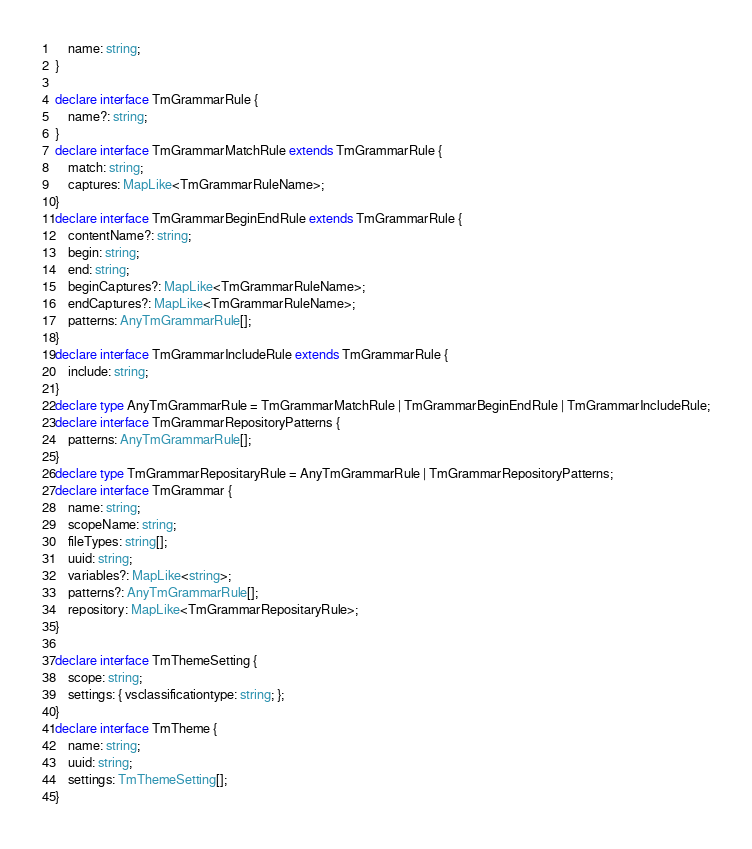<code> <loc_0><loc_0><loc_500><loc_500><_TypeScript_>    name: string;
}

declare interface TmGrammarRule {
    name?: string;
}
declare interface TmGrammarMatchRule extends TmGrammarRule {
    match: string;
    captures: MapLike<TmGrammarRuleName>;
}
declare interface TmGrammarBeginEndRule extends TmGrammarRule {
    contentName?: string;
    begin: string;
    end: string;
    beginCaptures?: MapLike<TmGrammarRuleName>;
    endCaptures?: MapLike<TmGrammarRuleName>;
    patterns: AnyTmGrammarRule[];
}
declare interface TmGrammarIncludeRule extends TmGrammarRule {
    include: string;
}
declare type AnyTmGrammarRule = TmGrammarMatchRule | TmGrammarBeginEndRule | TmGrammarIncludeRule;
declare interface TmGrammarRepositoryPatterns {
    patterns: AnyTmGrammarRule[];
}
declare type TmGrammarRepositaryRule = AnyTmGrammarRule | TmGrammarRepositoryPatterns;
declare interface TmGrammar {
    name: string;
    scopeName: string;
    fileTypes: string[];
    uuid: string;
    variables?: MapLike<string>;
    patterns?: AnyTmGrammarRule[];
    repository: MapLike<TmGrammarRepositaryRule>;
}

declare interface TmThemeSetting {
    scope: string;
    settings: { vsclassificationtype: string; };
}
declare interface TmTheme {
    name: string;
    uuid: string;
    settings: TmThemeSetting[];
}</code> 